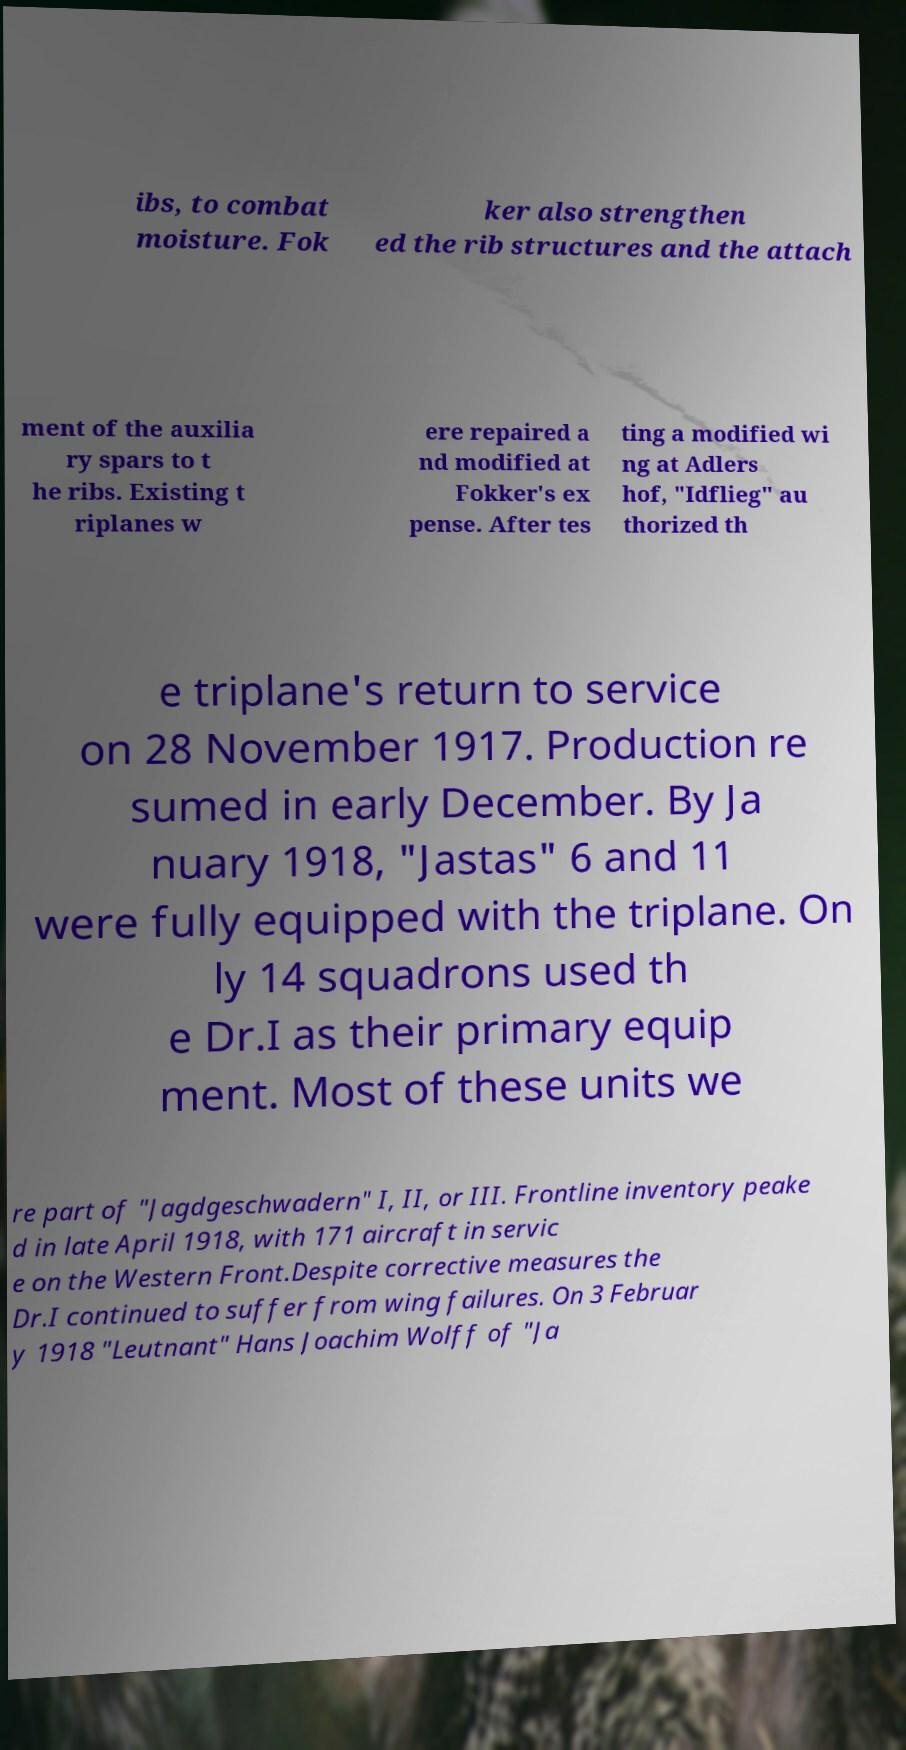For documentation purposes, I need the text within this image transcribed. Could you provide that? ibs, to combat moisture. Fok ker also strengthen ed the rib structures and the attach ment of the auxilia ry spars to t he ribs. Existing t riplanes w ere repaired a nd modified at Fokker's ex pense. After tes ting a modified wi ng at Adlers hof, "Idflieg" au thorized th e triplane's return to service on 28 November 1917. Production re sumed in early December. By Ja nuary 1918, "Jastas" 6 and 11 were fully equipped with the triplane. On ly 14 squadrons used th e Dr.I as their primary equip ment. Most of these units we re part of "Jagdgeschwadern" I, II, or III. Frontline inventory peake d in late April 1918, with 171 aircraft in servic e on the Western Front.Despite corrective measures the Dr.I continued to suffer from wing failures. On 3 Februar y 1918 "Leutnant" Hans Joachim Wolff of "Ja 